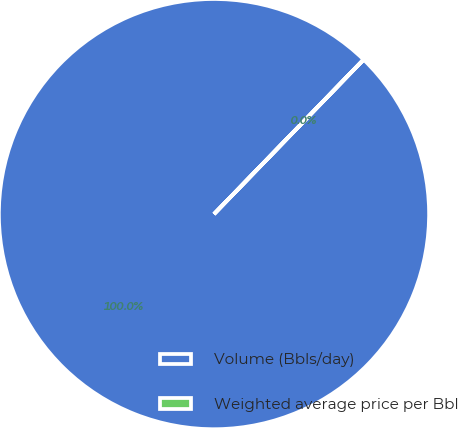Convert chart to OTSL. <chart><loc_0><loc_0><loc_500><loc_500><pie_chart><fcel>Volume (Bbls/day)<fcel>Weighted average price per Bbl<nl><fcel>99.99%<fcel>0.01%<nl></chart> 